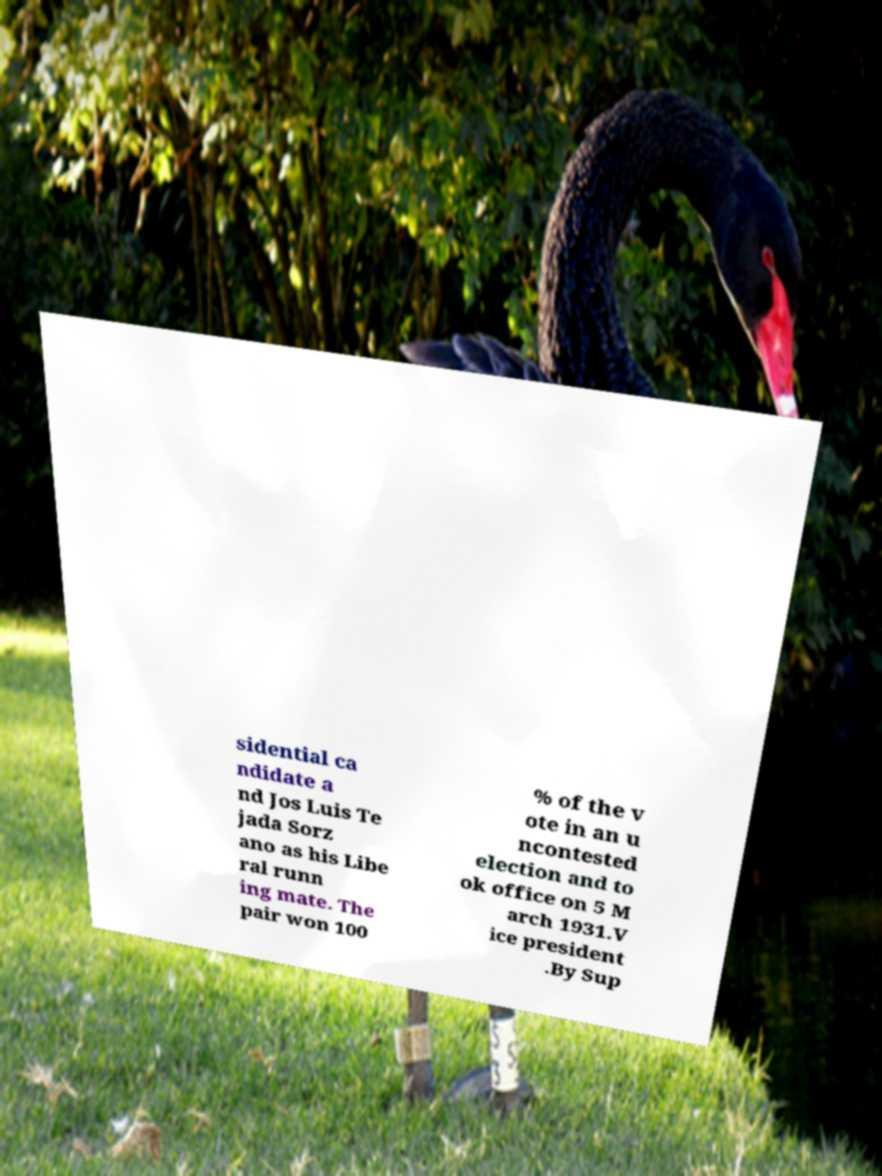Can you accurately transcribe the text from the provided image for me? sidential ca ndidate a nd Jos Luis Te jada Sorz ano as his Libe ral runn ing mate. The pair won 100 % of the v ote in an u ncontested election and to ok office on 5 M arch 1931.V ice president .By Sup 